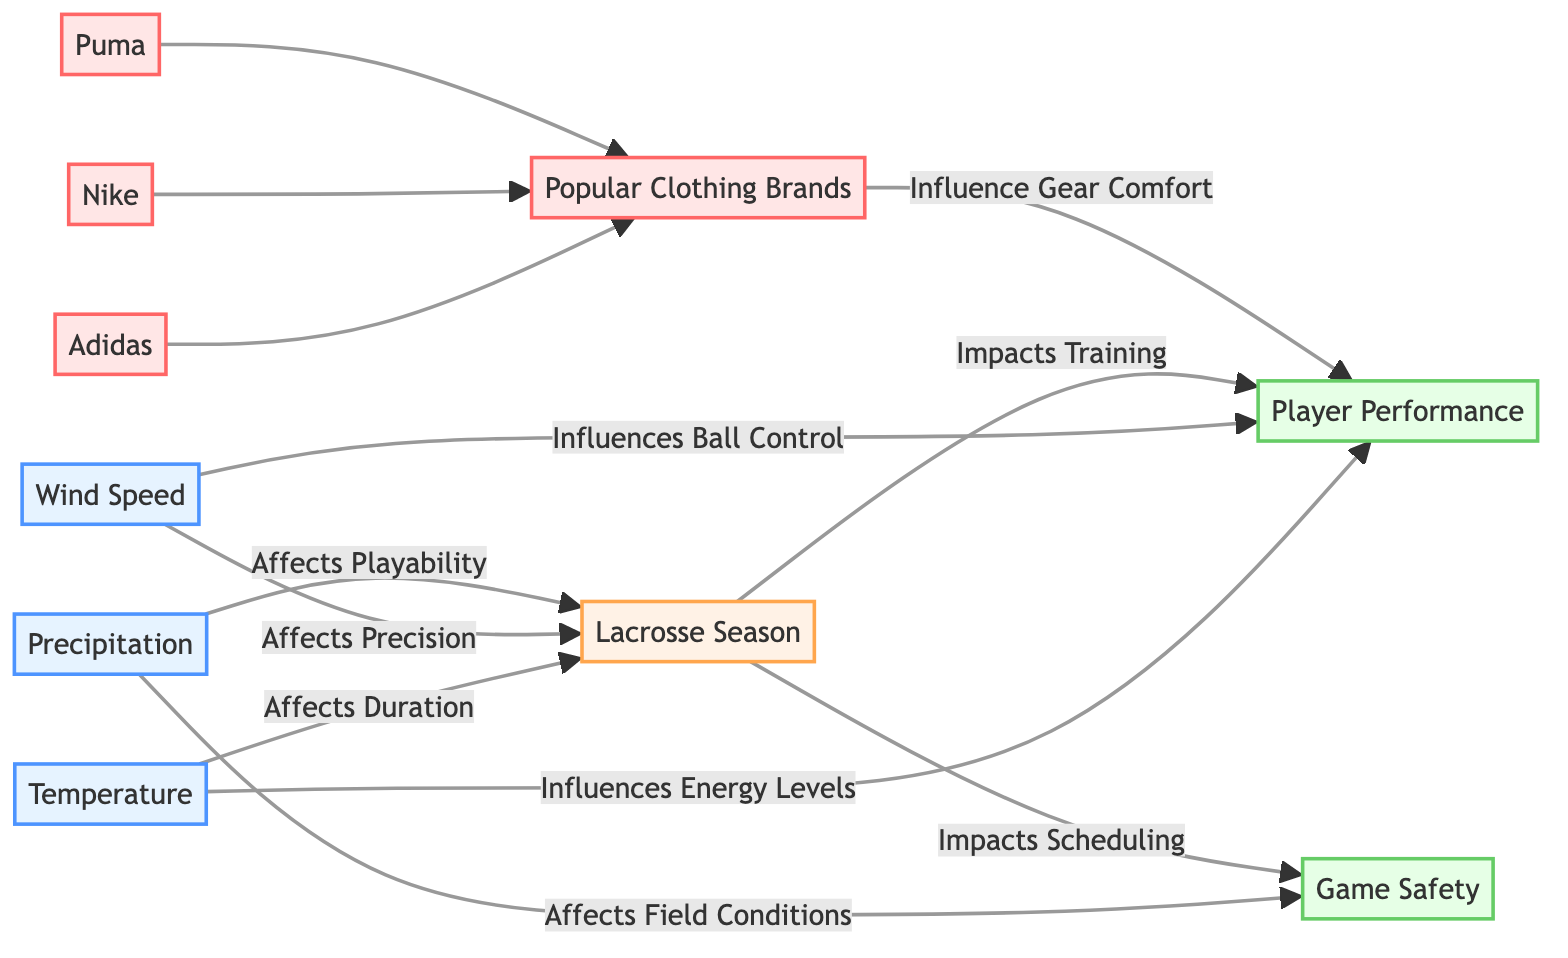What weather factor affects the duration of the lacrosse season? The diagram indicates that temperature affects the duration of the lacrosse season by visually connecting the Temperature node to the Lacrosse Season node with an arrow.
Answer: Temperature Which brand influences gear comfort? The diagram highlights that popular clothing brands influence gear comfort, indicated by an arrow from the Popular Brands node to the Player Performance node.
Answer: Popular Brands How does wind speed affect player performance? According to the diagram, wind speed influences ball control which is a component of player performance, as illustrated by the connection from Wind Speed to Player Performance.
Answer: Ball Control What is the main impact of precipitation on game safety? The diagram illustrates that precipitation affects field conditions, which relates to game safety, shown by the connection between the Precipitation node and Game Safety node.
Answer: Field Conditions How many popular clothing brands are mentioned? The diagram lists three popular brands (Adidas, Nike, and Puma) that all connect to the Popular Brands node, clearly visualizing their count.
Answer: Three What factors affect player performance as per the diagram? The diagram shows two arrows leading to Player Performance, from Temperature (influencing energy levels) and Wind Speed (influencing ball control), indicating multiple factors affecting player performance.
Answer: Temperature and Wind Speed What node is affected by wind speed in terms of precision? The diagram states that wind speed affects the lacrosse season, depicted by the directed edge from Wind Speed to the Lacrosse Season node.
Answer: Lacrosse Season How does temperature influence player performance? The diagram displays that temperature influences energy levels, linking the Temperature node to the Player Performance node, detailing the effect of temperature on player energy.
Answer: Energy Levels 